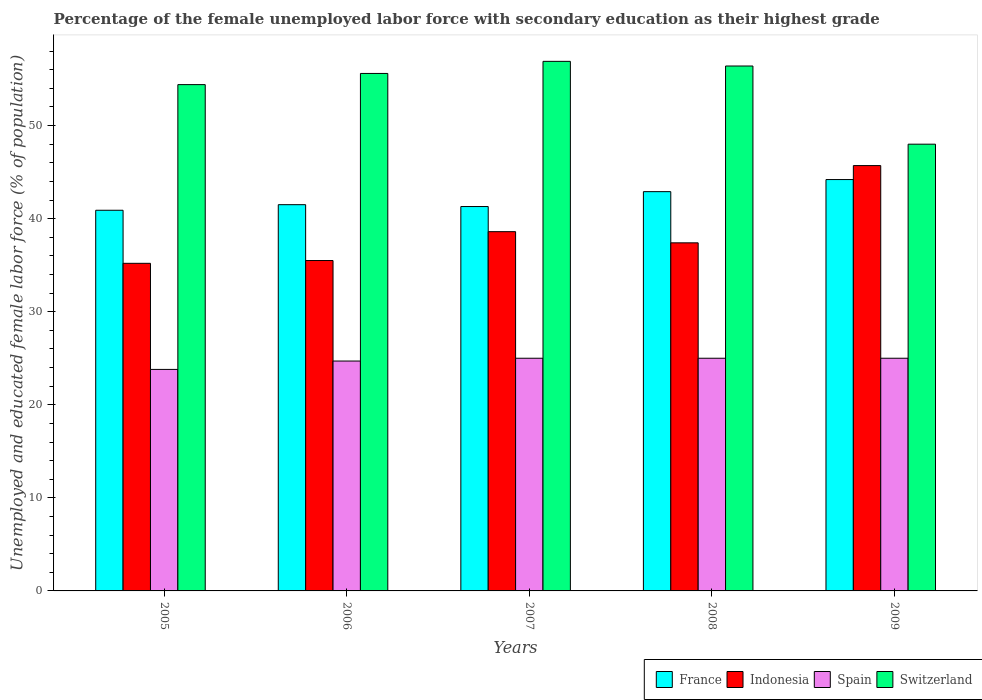How many different coloured bars are there?
Keep it short and to the point. 4. Are the number of bars per tick equal to the number of legend labels?
Offer a very short reply. Yes. How many bars are there on the 2nd tick from the right?
Your response must be concise. 4. What is the percentage of the unemployed female labor force with secondary education in Switzerland in 2007?
Provide a short and direct response. 56.9. Across all years, what is the maximum percentage of the unemployed female labor force with secondary education in Indonesia?
Provide a succinct answer. 45.7. Across all years, what is the minimum percentage of the unemployed female labor force with secondary education in Indonesia?
Ensure brevity in your answer.  35.2. What is the total percentage of the unemployed female labor force with secondary education in Indonesia in the graph?
Provide a short and direct response. 192.4. What is the difference between the percentage of the unemployed female labor force with secondary education in Spain in 2005 and the percentage of the unemployed female labor force with secondary education in France in 2009?
Offer a terse response. -20.4. What is the average percentage of the unemployed female labor force with secondary education in France per year?
Offer a terse response. 42.16. In the year 2006, what is the difference between the percentage of the unemployed female labor force with secondary education in France and percentage of the unemployed female labor force with secondary education in Indonesia?
Ensure brevity in your answer.  6. What is the ratio of the percentage of the unemployed female labor force with secondary education in France in 2005 to that in 2008?
Your answer should be very brief. 0.95. Is the percentage of the unemployed female labor force with secondary education in France in 2007 less than that in 2009?
Your answer should be compact. Yes. What is the difference between the highest and the second highest percentage of the unemployed female labor force with secondary education in Spain?
Offer a terse response. 0. What is the difference between the highest and the lowest percentage of the unemployed female labor force with secondary education in France?
Your answer should be very brief. 3.3. In how many years, is the percentage of the unemployed female labor force with secondary education in Switzerland greater than the average percentage of the unemployed female labor force with secondary education in Switzerland taken over all years?
Give a very brief answer. 4. Is the sum of the percentage of the unemployed female labor force with secondary education in France in 2007 and 2008 greater than the maximum percentage of the unemployed female labor force with secondary education in Switzerland across all years?
Offer a very short reply. Yes. Is it the case that in every year, the sum of the percentage of the unemployed female labor force with secondary education in Spain and percentage of the unemployed female labor force with secondary education in France is greater than the sum of percentage of the unemployed female labor force with secondary education in Indonesia and percentage of the unemployed female labor force with secondary education in Switzerland?
Provide a short and direct response. No. What does the 1st bar from the left in 2005 represents?
Offer a very short reply. France. What does the 2nd bar from the right in 2005 represents?
Your response must be concise. Spain. Is it the case that in every year, the sum of the percentage of the unemployed female labor force with secondary education in Spain and percentage of the unemployed female labor force with secondary education in Indonesia is greater than the percentage of the unemployed female labor force with secondary education in France?
Your response must be concise. Yes. How many bars are there?
Offer a very short reply. 20. Does the graph contain any zero values?
Provide a succinct answer. No. Does the graph contain grids?
Ensure brevity in your answer.  No. Where does the legend appear in the graph?
Give a very brief answer. Bottom right. How are the legend labels stacked?
Provide a succinct answer. Horizontal. What is the title of the graph?
Give a very brief answer. Percentage of the female unemployed labor force with secondary education as their highest grade. Does "Aruba" appear as one of the legend labels in the graph?
Provide a short and direct response. No. What is the label or title of the X-axis?
Offer a terse response. Years. What is the label or title of the Y-axis?
Your response must be concise. Unemployed and educated female labor force (% of population). What is the Unemployed and educated female labor force (% of population) of France in 2005?
Ensure brevity in your answer.  40.9. What is the Unemployed and educated female labor force (% of population) in Indonesia in 2005?
Your answer should be very brief. 35.2. What is the Unemployed and educated female labor force (% of population) in Spain in 2005?
Offer a terse response. 23.8. What is the Unemployed and educated female labor force (% of population) in Switzerland in 2005?
Offer a terse response. 54.4. What is the Unemployed and educated female labor force (% of population) of France in 2006?
Your answer should be compact. 41.5. What is the Unemployed and educated female labor force (% of population) of Indonesia in 2006?
Provide a succinct answer. 35.5. What is the Unemployed and educated female labor force (% of population) in Spain in 2006?
Your answer should be very brief. 24.7. What is the Unemployed and educated female labor force (% of population) of Switzerland in 2006?
Give a very brief answer. 55.6. What is the Unemployed and educated female labor force (% of population) in France in 2007?
Offer a terse response. 41.3. What is the Unemployed and educated female labor force (% of population) in Indonesia in 2007?
Make the answer very short. 38.6. What is the Unemployed and educated female labor force (% of population) in Spain in 2007?
Your answer should be very brief. 25. What is the Unemployed and educated female labor force (% of population) in Switzerland in 2007?
Ensure brevity in your answer.  56.9. What is the Unemployed and educated female labor force (% of population) in France in 2008?
Your answer should be very brief. 42.9. What is the Unemployed and educated female labor force (% of population) in Indonesia in 2008?
Offer a very short reply. 37.4. What is the Unemployed and educated female labor force (% of population) in Switzerland in 2008?
Provide a succinct answer. 56.4. What is the Unemployed and educated female labor force (% of population) in France in 2009?
Provide a succinct answer. 44.2. What is the Unemployed and educated female labor force (% of population) of Indonesia in 2009?
Offer a terse response. 45.7. What is the Unemployed and educated female labor force (% of population) in Spain in 2009?
Keep it short and to the point. 25. What is the Unemployed and educated female labor force (% of population) of Switzerland in 2009?
Provide a succinct answer. 48. Across all years, what is the maximum Unemployed and educated female labor force (% of population) of France?
Your answer should be compact. 44.2. Across all years, what is the maximum Unemployed and educated female labor force (% of population) of Indonesia?
Offer a very short reply. 45.7. Across all years, what is the maximum Unemployed and educated female labor force (% of population) of Spain?
Keep it short and to the point. 25. Across all years, what is the maximum Unemployed and educated female labor force (% of population) of Switzerland?
Offer a very short reply. 56.9. Across all years, what is the minimum Unemployed and educated female labor force (% of population) of France?
Provide a short and direct response. 40.9. Across all years, what is the minimum Unemployed and educated female labor force (% of population) in Indonesia?
Your answer should be compact. 35.2. Across all years, what is the minimum Unemployed and educated female labor force (% of population) of Spain?
Provide a succinct answer. 23.8. What is the total Unemployed and educated female labor force (% of population) in France in the graph?
Provide a short and direct response. 210.8. What is the total Unemployed and educated female labor force (% of population) of Indonesia in the graph?
Make the answer very short. 192.4. What is the total Unemployed and educated female labor force (% of population) of Spain in the graph?
Ensure brevity in your answer.  123.5. What is the total Unemployed and educated female labor force (% of population) of Switzerland in the graph?
Provide a short and direct response. 271.3. What is the difference between the Unemployed and educated female labor force (% of population) of Spain in 2005 and that in 2007?
Ensure brevity in your answer.  -1.2. What is the difference between the Unemployed and educated female labor force (% of population) in Switzerland in 2005 and that in 2007?
Give a very brief answer. -2.5. What is the difference between the Unemployed and educated female labor force (% of population) of France in 2005 and that in 2008?
Provide a short and direct response. -2. What is the difference between the Unemployed and educated female labor force (% of population) of Indonesia in 2005 and that in 2008?
Offer a terse response. -2.2. What is the difference between the Unemployed and educated female labor force (% of population) in Spain in 2005 and that in 2008?
Keep it short and to the point. -1.2. What is the difference between the Unemployed and educated female labor force (% of population) of France in 2005 and that in 2009?
Your answer should be compact. -3.3. What is the difference between the Unemployed and educated female labor force (% of population) in Indonesia in 2005 and that in 2009?
Your answer should be compact. -10.5. What is the difference between the Unemployed and educated female labor force (% of population) in France in 2006 and that in 2007?
Offer a very short reply. 0.2. What is the difference between the Unemployed and educated female labor force (% of population) in Indonesia in 2006 and that in 2007?
Your answer should be very brief. -3.1. What is the difference between the Unemployed and educated female labor force (% of population) in Spain in 2006 and that in 2007?
Offer a terse response. -0.3. What is the difference between the Unemployed and educated female labor force (% of population) of Switzerland in 2006 and that in 2007?
Your answer should be compact. -1.3. What is the difference between the Unemployed and educated female labor force (% of population) of France in 2006 and that in 2008?
Provide a short and direct response. -1.4. What is the difference between the Unemployed and educated female labor force (% of population) of Spain in 2006 and that in 2009?
Your answer should be very brief. -0.3. What is the difference between the Unemployed and educated female labor force (% of population) of Switzerland in 2006 and that in 2009?
Give a very brief answer. 7.6. What is the difference between the Unemployed and educated female labor force (% of population) in France in 2007 and that in 2008?
Make the answer very short. -1.6. What is the difference between the Unemployed and educated female labor force (% of population) of France in 2005 and the Unemployed and educated female labor force (% of population) of Indonesia in 2006?
Provide a succinct answer. 5.4. What is the difference between the Unemployed and educated female labor force (% of population) of France in 2005 and the Unemployed and educated female labor force (% of population) of Switzerland in 2006?
Keep it short and to the point. -14.7. What is the difference between the Unemployed and educated female labor force (% of population) in Indonesia in 2005 and the Unemployed and educated female labor force (% of population) in Spain in 2006?
Give a very brief answer. 10.5. What is the difference between the Unemployed and educated female labor force (% of population) of Indonesia in 2005 and the Unemployed and educated female labor force (% of population) of Switzerland in 2006?
Ensure brevity in your answer.  -20.4. What is the difference between the Unemployed and educated female labor force (% of population) of Spain in 2005 and the Unemployed and educated female labor force (% of population) of Switzerland in 2006?
Provide a short and direct response. -31.8. What is the difference between the Unemployed and educated female labor force (% of population) of France in 2005 and the Unemployed and educated female labor force (% of population) of Indonesia in 2007?
Provide a short and direct response. 2.3. What is the difference between the Unemployed and educated female labor force (% of population) of France in 2005 and the Unemployed and educated female labor force (% of population) of Switzerland in 2007?
Offer a very short reply. -16. What is the difference between the Unemployed and educated female labor force (% of population) of Indonesia in 2005 and the Unemployed and educated female labor force (% of population) of Spain in 2007?
Offer a very short reply. 10.2. What is the difference between the Unemployed and educated female labor force (% of population) in Indonesia in 2005 and the Unemployed and educated female labor force (% of population) in Switzerland in 2007?
Make the answer very short. -21.7. What is the difference between the Unemployed and educated female labor force (% of population) in Spain in 2005 and the Unemployed and educated female labor force (% of population) in Switzerland in 2007?
Ensure brevity in your answer.  -33.1. What is the difference between the Unemployed and educated female labor force (% of population) in France in 2005 and the Unemployed and educated female labor force (% of population) in Switzerland in 2008?
Your answer should be compact. -15.5. What is the difference between the Unemployed and educated female labor force (% of population) in Indonesia in 2005 and the Unemployed and educated female labor force (% of population) in Switzerland in 2008?
Make the answer very short. -21.2. What is the difference between the Unemployed and educated female labor force (% of population) in Spain in 2005 and the Unemployed and educated female labor force (% of population) in Switzerland in 2008?
Offer a very short reply. -32.6. What is the difference between the Unemployed and educated female labor force (% of population) in France in 2005 and the Unemployed and educated female labor force (% of population) in Indonesia in 2009?
Your response must be concise. -4.8. What is the difference between the Unemployed and educated female labor force (% of population) of France in 2005 and the Unemployed and educated female labor force (% of population) of Switzerland in 2009?
Your response must be concise. -7.1. What is the difference between the Unemployed and educated female labor force (% of population) in Indonesia in 2005 and the Unemployed and educated female labor force (% of population) in Switzerland in 2009?
Offer a very short reply. -12.8. What is the difference between the Unemployed and educated female labor force (% of population) of Spain in 2005 and the Unemployed and educated female labor force (% of population) of Switzerland in 2009?
Keep it short and to the point. -24.2. What is the difference between the Unemployed and educated female labor force (% of population) of France in 2006 and the Unemployed and educated female labor force (% of population) of Indonesia in 2007?
Your answer should be compact. 2.9. What is the difference between the Unemployed and educated female labor force (% of population) of France in 2006 and the Unemployed and educated female labor force (% of population) of Spain in 2007?
Provide a short and direct response. 16.5. What is the difference between the Unemployed and educated female labor force (% of population) of France in 2006 and the Unemployed and educated female labor force (% of population) of Switzerland in 2007?
Ensure brevity in your answer.  -15.4. What is the difference between the Unemployed and educated female labor force (% of population) in Indonesia in 2006 and the Unemployed and educated female labor force (% of population) in Switzerland in 2007?
Ensure brevity in your answer.  -21.4. What is the difference between the Unemployed and educated female labor force (% of population) in Spain in 2006 and the Unemployed and educated female labor force (% of population) in Switzerland in 2007?
Your answer should be very brief. -32.2. What is the difference between the Unemployed and educated female labor force (% of population) of France in 2006 and the Unemployed and educated female labor force (% of population) of Indonesia in 2008?
Offer a terse response. 4.1. What is the difference between the Unemployed and educated female labor force (% of population) of France in 2006 and the Unemployed and educated female labor force (% of population) of Spain in 2008?
Keep it short and to the point. 16.5. What is the difference between the Unemployed and educated female labor force (% of population) in France in 2006 and the Unemployed and educated female labor force (% of population) in Switzerland in 2008?
Ensure brevity in your answer.  -14.9. What is the difference between the Unemployed and educated female labor force (% of population) in Indonesia in 2006 and the Unemployed and educated female labor force (% of population) in Spain in 2008?
Offer a terse response. 10.5. What is the difference between the Unemployed and educated female labor force (% of population) of Indonesia in 2006 and the Unemployed and educated female labor force (% of population) of Switzerland in 2008?
Make the answer very short. -20.9. What is the difference between the Unemployed and educated female labor force (% of population) of Spain in 2006 and the Unemployed and educated female labor force (% of population) of Switzerland in 2008?
Your response must be concise. -31.7. What is the difference between the Unemployed and educated female labor force (% of population) in France in 2006 and the Unemployed and educated female labor force (% of population) in Spain in 2009?
Provide a short and direct response. 16.5. What is the difference between the Unemployed and educated female labor force (% of population) of France in 2006 and the Unemployed and educated female labor force (% of population) of Switzerland in 2009?
Provide a short and direct response. -6.5. What is the difference between the Unemployed and educated female labor force (% of population) in Spain in 2006 and the Unemployed and educated female labor force (% of population) in Switzerland in 2009?
Offer a terse response. -23.3. What is the difference between the Unemployed and educated female labor force (% of population) of France in 2007 and the Unemployed and educated female labor force (% of population) of Switzerland in 2008?
Your answer should be very brief. -15.1. What is the difference between the Unemployed and educated female labor force (% of population) of Indonesia in 2007 and the Unemployed and educated female labor force (% of population) of Switzerland in 2008?
Provide a short and direct response. -17.8. What is the difference between the Unemployed and educated female labor force (% of population) of Spain in 2007 and the Unemployed and educated female labor force (% of population) of Switzerland in 2008?
Provide a short and direct response. -31.4. What is the difference between the Unemployed and educated female labor force (% of population) in France in 2007 and the Unemployed and educated female labor force (% of population) in Spain in 2009?
Your response must be concise. 16.3. What is the difference between the Unemployed and educated female labor force (% of population) of Indonesia in 2007 and the Unemployed and educated female labor force (% of population) of Switzerland in 2009?
Offer a very short reply. -9.4. What is the difference between the Unemployed and educated female labor force (% of population) in France in 2008 and the Unemployed and educated female labor force (% of population) in Indonesia in 2009?
Your answer should be very brief. -2.8. What is the difference between the Unemployed and educated female labor force (% of population) of France in 2008 and the Unemployed and educated female labor force (% of population) of Switzerland in 2009?
Provide a succinct answer. -5.1. What is the difference between the Unemployed and educated female labor force (% of population) of Indonesia in 2008 and the Unemployed and educated female labor force (% of population) of Spain in 2009?
Keep it short and to the point. 12.4. What is the average Unemployed and educated female labor force (% of population) in France per year?
Offer a very short reply. 42.16. What is the average Unemployed and educated female labor force (% of population) of Indonesia per year?
Your answer should be compact. 38.48. What is the average Unemployed and educated female labor force (% of population) in Spain per year?
Ensure brevity in your answer.  24.7. What is the average Unemployed and educated female labor force (% of population) of Switzerland per year?
Make the answer very short. 54.26. In the year 2005, what is the difference between the Unemployed and educated female labor force (% of population) in France and Unemployed and educated female labor force (% of population) in Indonesia?
Provide a succinct answer. 5.7. In the year 2005, what is the difference between the Unemployed and educated female labor force (% of population) in France and Unemployed and educated female labor force (% of population) in Spain?
Provide a succinct answer. 17.1. In the year 2005, what is the difference between the Unemployed and educated female labor force (% of population) in Indonesia and Unemployed and educated female labor force (% of population) in Spain?
Offer a very short reply. 11.4. In the year 2005, what is the difference between the Unemployed and educated female labor force (% of population) of Indonesia and Unemployed and educated female labor force (% of population) of Switzerland?
Your answer should be compact. -19.2. In the year 2005, what is the difference between the Unemployed and educated female labor force (% of population) of Spain and Unemployed and educated female labor force (% of population) of Switzerland?
Provide a succinct answer. -30.6. In the year 2006, what is the difference between the Unemployed and educated female labor force (% of population) in France and Unemployed and educated female labor force (% of population) in Indonesia?
Make the answer very short. 6. In the year 2006, what is the difference between the Unemployed and educated female labor force (% of population) in France and Unemployed and educated female labor force (% of population) in Switzerland?
Keep it short and to the point. -14.1. In the year 2006, what is the difference between the Unemployed and educated female labor force (% of population) of Indonesia and Unemployed and educated female labor force (% of population) of Spain?
Give a very brief answer. 10.8. In the year 2006, what is the difference between the Unemployed and educated female labor force (% of population) of Indonesia and Unemployed and educated female labor force (% of population) of Switzerland?
Ensure brevity in your answer.  -20.1. In the year 2006, what is the difference between the Unemployed and educated female labor force (% of population) of Spain and Unemployed and educated female labor force (% of population) of Switzerland?
Make the answer very short. -30.9. In the year 2007, what is the difference between the Unemployed and educated female labor force (% of population) in France and Unemployed and educated female labor force (% of population) in Indonesia?
Ensure brevity in your answer.  2.7. In the year 2007, what is the difference between the Unemployed and educated female labor force (% of population) in France and Unemployed and educated female labor force (% of population) in Switzerland?
Ensure brevity in your answer.  -15.6. In the year 2007, what is the difference between the Unemployed and educated female labor force (% of population) in Indonesia and Unemployed and educated female labor force (% of population) in Spain?
Make the answer very short. 13.6. In the year 2007, what is the difference between the Unemployed and educated female labor force (% of population) in Indonesia and Unemployed and educated female labor force (% of population) in Switzerland?
Keep it short and to the point. -18.3. In the year 2007, what is the difference between the Unemployed and educated female labor force (% of population) of Spain and Unemployed and educated female labor force (% of population) of Switzerland?
Your response must be concise. -31.9. In the year 2008, what is the difference between the Unemployed and educated female labor force (% of population) in France and Unemployed and educated female labor force (% of population) in Indonesia?
Your answer should be compact. 5.5. In the year 2008, what is the difference between the Unemployed and educated female labor force (% of population) in France and Unemployed and educated female labor force (% of population) in Spain?
Keep it short and to the point. 17.9. In the year 2008, what is the difference between the Unemployed and educated female labor force (% of population) of Indonesia and Unemployed and educated female labor force (% of population) of Spain?
Keep it short and to the point. 12.4. In the year 2008, what is the difference between the Unemployed and educated female labor force (% of population) of Indonesia and Unemployed and educated female labor force (% of population) of Switzerland?
Your response must be concise. -19. In the year 2008, what is the difference between the Unemployed and educated female labor force (% of population) in Spain and Unemployed and educated female labor force (% of population) in Switzerland?
Give a very brief answer. -31.4. In the year 2009, what is the difference between the Unemployed and educated female labor force (% of population) of Indonesia and Unemployed and educated female labor force (% of population) of Spain?
Your answer should be compact. 20.7. In the year 2009, what is the difference between the Unemployed and educated female labor force (% of population) of Indonesia and Unemployed and educated female labor force (% of population) of Switzerland?
Make the answer very short. -2.3. What is the ratio of the Unemployed and educated female labor force (% of population) of France in 2005 to that in 2006?
Your answer should be compact. 0.99. What is the ratio of the Unemployed and educated female labor force (% of population) of Indonesia in 2005 to that in 2006?
Your answer should be compact. 0.99. What is the ratio of the Unemployed and educated female labor force (% of population) of Spain in 2005 to that in 2006?
Offer a very short reply. 0.96. What is the ratio of the Unemployed and educated female labor force (% of population) in Switzerland in 2005 to that in 2006?
Your answer should be compact. 0.98. What is the ratio of the Unemployed and educated female labor force (% of population) in France in 2005 to that in 2007?
Offer a terse response. 0.99. What is the ratio of the Unemployed and educated female labor force (% of population) of Indonesia in 2005 to that in 2007?
Give a very brief answer. 0.91. What is the ratio of the Unemployed and educated female labor force (% of population) of Spain in 2005 to that in 2007?
Keep it short and to the point. 0.95. What is the ratio of the Unemployed and educated female labor force (% of population) in Switzerland in 2005 to that in 2007?
Give a very brief answer. 0.96. What is the ratio of the Unemployed and educated female labor force (% of population) in France in 2005 to that in 2008?
Ensure brevity in your answer.  0.95. What is the ratio of the Unemployed and educated female labor force (% of population) of Indonesia in 2005 to that in 2008?
Provide a succinct answer. 0.94. What is the ratio of the Unemployed and educated female labor force (% of population) of Switzerland in 2005 to that in 2008?
Offer a terse response. 0.96. What is the ratio of the Unemployed and educated female labor force (% of population) in France in 2005 to that in 2009?
Ensure brevity in your answer.  0.93. What is the ratio of the Unemployed and educated female labor force (% of population) of Indonesia in 2005 to that in 2009?
Your response must be concise. 0.77. What is the ratio of the Unemployed and educated female labor force (% of population) in Spain in 2005 to that in 2009?
Provide a succinct answer. 0.95. What is the ratio of the Unemployed and educated female labor force (% of population) of Switzerland in 2005 to that in 2009?
Provide a short and direct response. 1.13. What is the ratio of the Unemployed and educated female labor force (% of population) in France in 2006 to that in 2007?
Your answer should be compact. 1. What is the ratio of the Unemployed and educated female labor force (% of population) of Indonesia in 2006 to that in 2007?
Offer a very short reply. 0.92. What is the ratio of the Unemployed and educated female labor force (% of population) in Switzerland in 2006 to that in 2007?
Keep it short and to the point. 0.98. What is the ratio of the Unemployed and educated female labor force (% of population) in France in 2006 to that in 2008?
Your response must be concise. 0.97. What is the ratio of the Unemployed and educated female labor force (% of population) of Indonesia in 2006 to that in 2008?
Make the answer very short. 0.95. What is the ratio of the Unemployed and educated female labor force (% of population) in Switzerland in 2006 to that in 2008?
Make the answer very short. 0.99. What is the ratio of the Unemployed and educated female labor force (% of population) in France in 2006 to that in 2009?
Your response must be concise. 0.94. What is the ratio of the Unemployed and educated female labor force (% of population) of Indonesia in 2006 to that in 2009?
Keep it short and to the point. 0.78. What is the ratio of the Unemployed and educated female labor force (% of population) of Spain in 2006 to that in 2009?
Ensure brevity in your answer.  0.99. What is the ratio of the Unemployed and educated female labor force (% of population) of Switzerland in 2006 to that in 2009?
Your answer should be compact. 1.16. What is the ratio of the Unemployed and educated female labor force (% of population) in France in 2007 to that in 2008?
Provide a succinct answer. 0.96. What is the ratio of the Unemployed and educated female labor force (% of population) in Indonesia in 2007 to that in 2008?
Provide a short and direct response. 1.03. What is the ratio of the Unemployed and educated female labor force (% of population) in Switzerland in 2007 to that in 2008?
Provide a short and direct response. 1.01. What is the ratio of the Unemployed and educated female labor force (% of population) in France in 2007 to that in 2009?
Your answer should be very brief. 0.93. What is the ratio of the Unemployed and educated female labor force (% of population) of Indonesia in 2007 to that in 2009?
Give a very brief answer. 0.84. What is the ratio of the Unemployed and educated female labor force (% of population) of Spain in 2007 to that in 2009?
Provide a short and direct response. 1. What is the ratio of the Unemployed and educated female labor force (% of population) in Switzerland in 2007 to that in 2009?
Ensure brevity in your answer.  1.19. What is the ratio of the Unemployed and educated female labor force (% of population) in France in 2008 to that in 2009?
Provide a succinct answer. 0.97. What is the ratio of the Unemployed and educated female labor force (% of population) of Indonesia in 2008 to that in 2009?
Give a very brief answer. 0.82. What is the ratio of the Unemployed and educated female labor force (% of population) of Switzerland in 2008 to that in 2009?
Offer a very short reply. 1.18. What is the difference between the highest and the second highest Unemployed and educated female labor force (% of population) of France?
Your answer should be very brief. 1.3. What is the difference between the highest and the second highest Unemployed and educated female labor force (% of population) of Switzerland?
Provide a short and direct response. 0.5. What is the difference between the highest and the lowest Unemployed and educated female labor force (% of population) of Spain?
Provide a short and direct response. 1.2. What is the difference between the highest and the lowest Unemployed and educated female labor force (% of population) of Switzerland?
Make the answer very short. 8.9. 